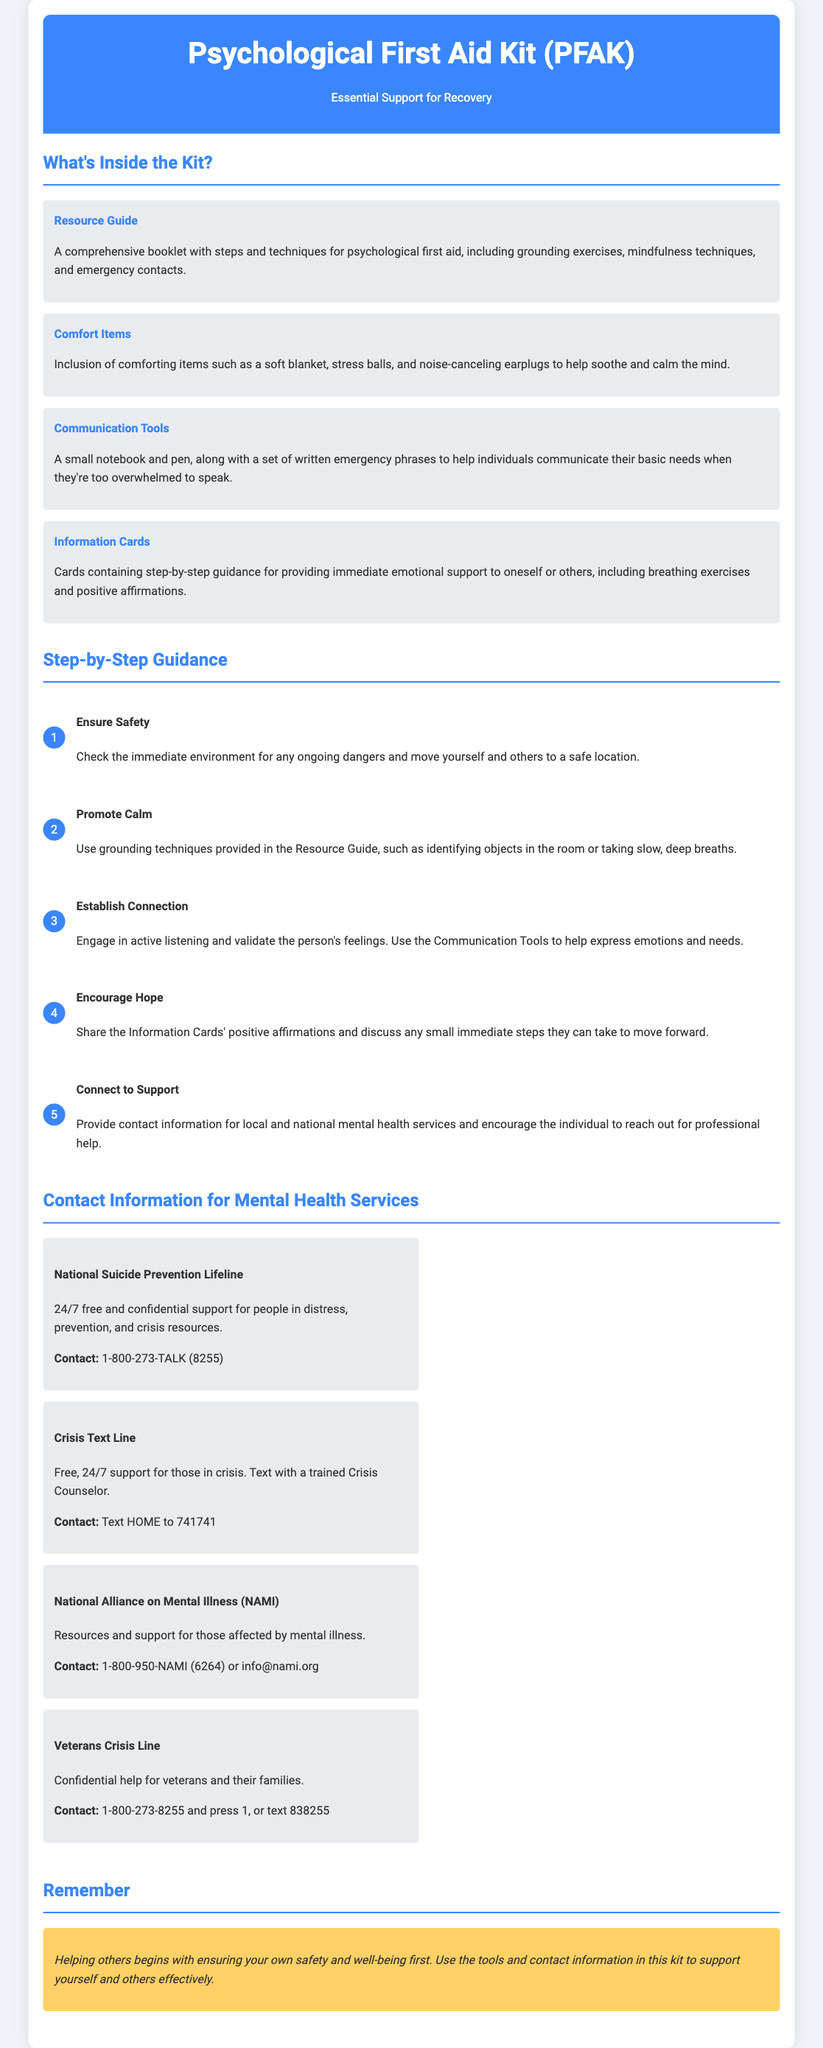What is the title of the kit? The title of the kit is prominently displayed at the top of the document in the header section.
Answer: Psychological First Aid Kit (PFAK) How many comfort items are mentioned? The document specifically lists one type of comfort item category, but it can be assumed that various items fall under that category.
Answer: One What is the first step in the guidance? The first step is outlined in the Step-by-Step Guidance section under a clear heading.
Answer: Ensure Safety What is the contact number for the National Suicide Prevention Lifeline? The contact number is provided in the Contact Information for Mental Health Services section.
Answer: 1-800-273-TALK (8255) What should you text to reach the Crisis Text Line? The document specifies the exact phrase that needs to be texted to contact this service.
Answer: HOME Which organization provides help specifically for veterans? The document highlights a specific resource aimed at veterans in the Contact Information section.
Answer: Veterans Crisis Line What is emphasized in the Remember section? The Remember section contains a crucial point or reminder that is critical for the user's understanding.
Answer: Helping others begins with ensuring your own safety and well-being first 